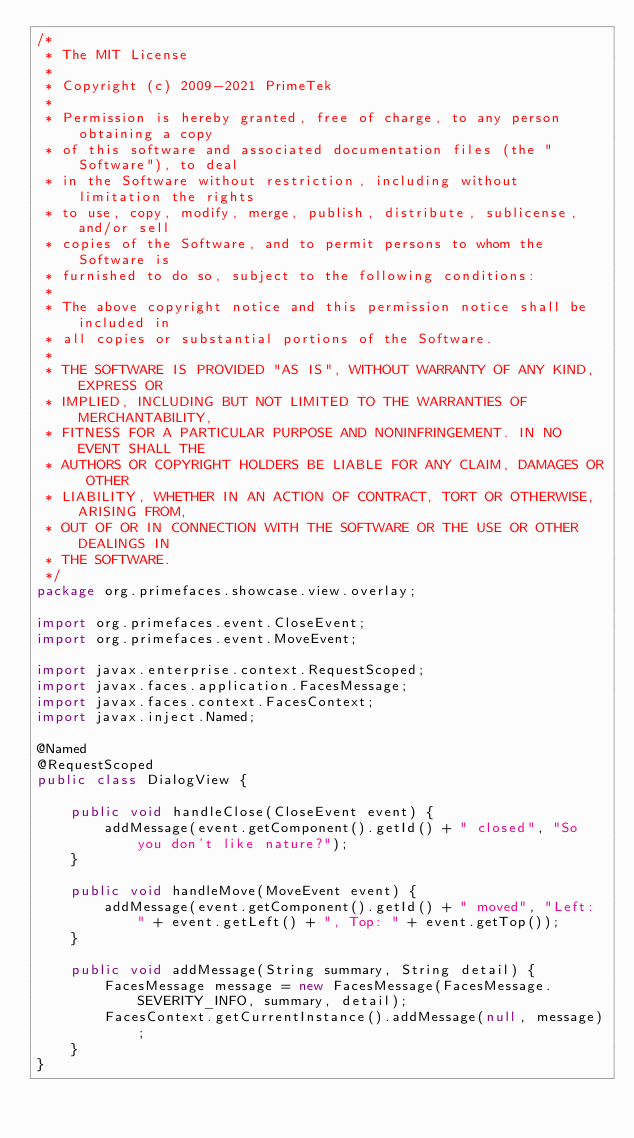<code> <loc_0><loc_0><loc_500><loc_500><_Java_>/*
 * The MIT License
 *
 * Copyright (c) 2009-2021 PrimeTek
 *
 * Permission is hereby granted, free of charge, to any person obtaining a copy
 * of this software and associated documentation files (the "Software"), to deal
 * in the Software without restriction, including without limitation the rights
 * to use, copy, modify, merge, publish, distribute, sublicense, and/or sell
 * copies of the Software, and to permit persons to whom the Software is
 * furnished to do so, subject to the following conditions:
 *
 * The above copyright notice and this permission notice shall be included in
 * all copies or substantial portions of the Software.
 *
 * THE SOFTWARE IS PROVIDED "AS IS", WITHOUT WARRANTY OF ANY KIND, EXPRESS OR
 * IMPLIED, INCLUDING BUT NOT LIMITED TO THE WARRANTIES OF MERCHANTABILITY,
 * FITNESS FOR A PARTICULAR PURPOSE AND NONINFRINGEMENT. IN NO EVENT SHALL THE
 * AUTHORS OR COPYRIGHT HOLDERS BE LIABLE FOR ANY CLAIM, DAMAGES OR OTHER
 * LIABILITY, WHETHER IN AN ACTION OF CONTRACT, TORT OR OTHERWISE, ARISING FROM,
 * OUT OF OR IN CONNECTION WITH THE SOFTWARE OR THE USE OR OTHER DEALINGS IN
 * THE SOFTWARE.
 */
package org.primefaces.showcase.view.overlay;

import org.primefaces.event.CloseEvent;
import org.primefaces.event.MoveEvent;

import javax.enterprise.context.RequestScoped;
import javax.faces.application.FacesMessage;
import javax.faces.context.FacesContext;
import javax.inject.Named;

@Named
@RequestScoped
public class DialogView {

    public void handleClose(CloseEvent event) {
        addMessage(event.getComponent().getId() + " closed", "So you don't like nature?");
    }

    public void handleMove(MoveEvent event) {
        addMessage(event.getComponent().getId() + " moved", "Left: " + event.getLeft() + ", Top: " + event.getTop());
    }

    public void addMessage(String summary, String detail) {
        FacesMessage message = new FacesMessage(FacesMessage.SEVERITY_INFO, summary, detail);
        FacesContext.getCurrentInstance().addMessage(null, message);
    }
}
</code> 